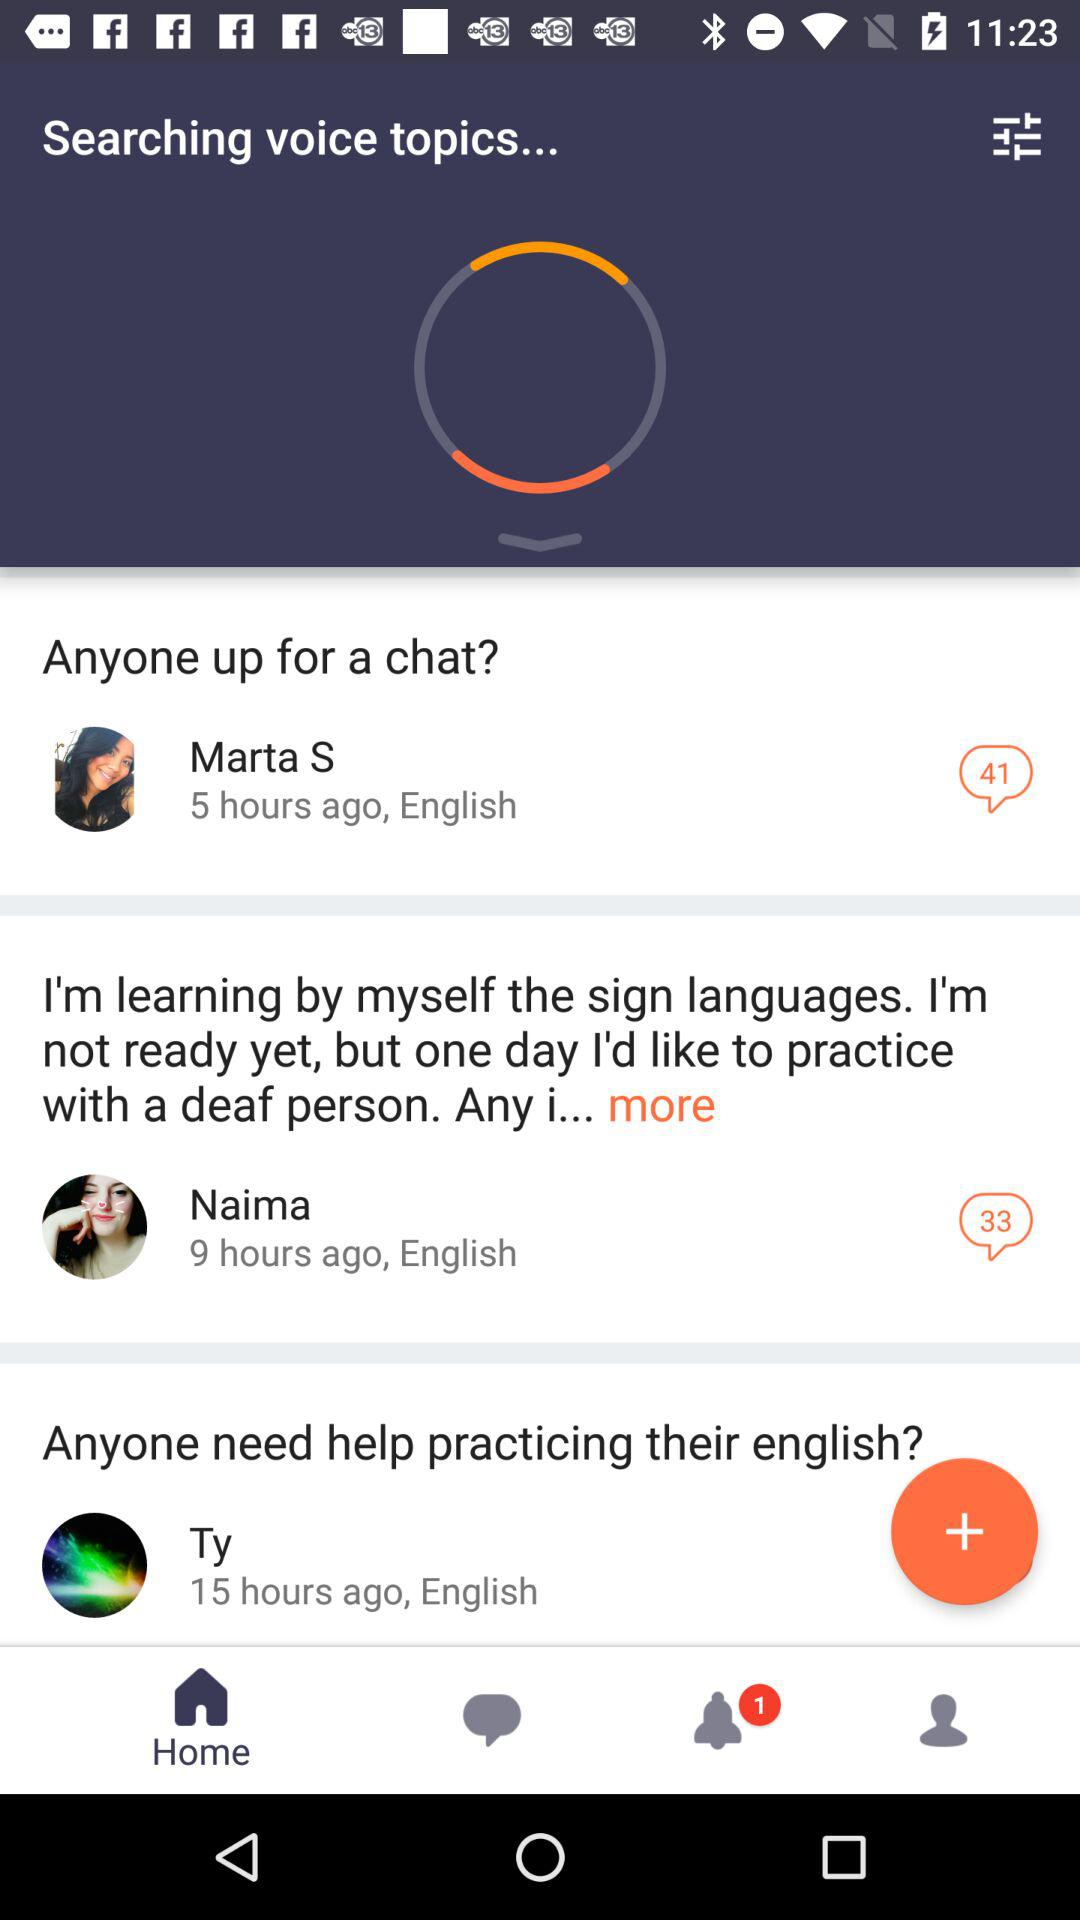Which tab is selected? The selected tab is "Home". 